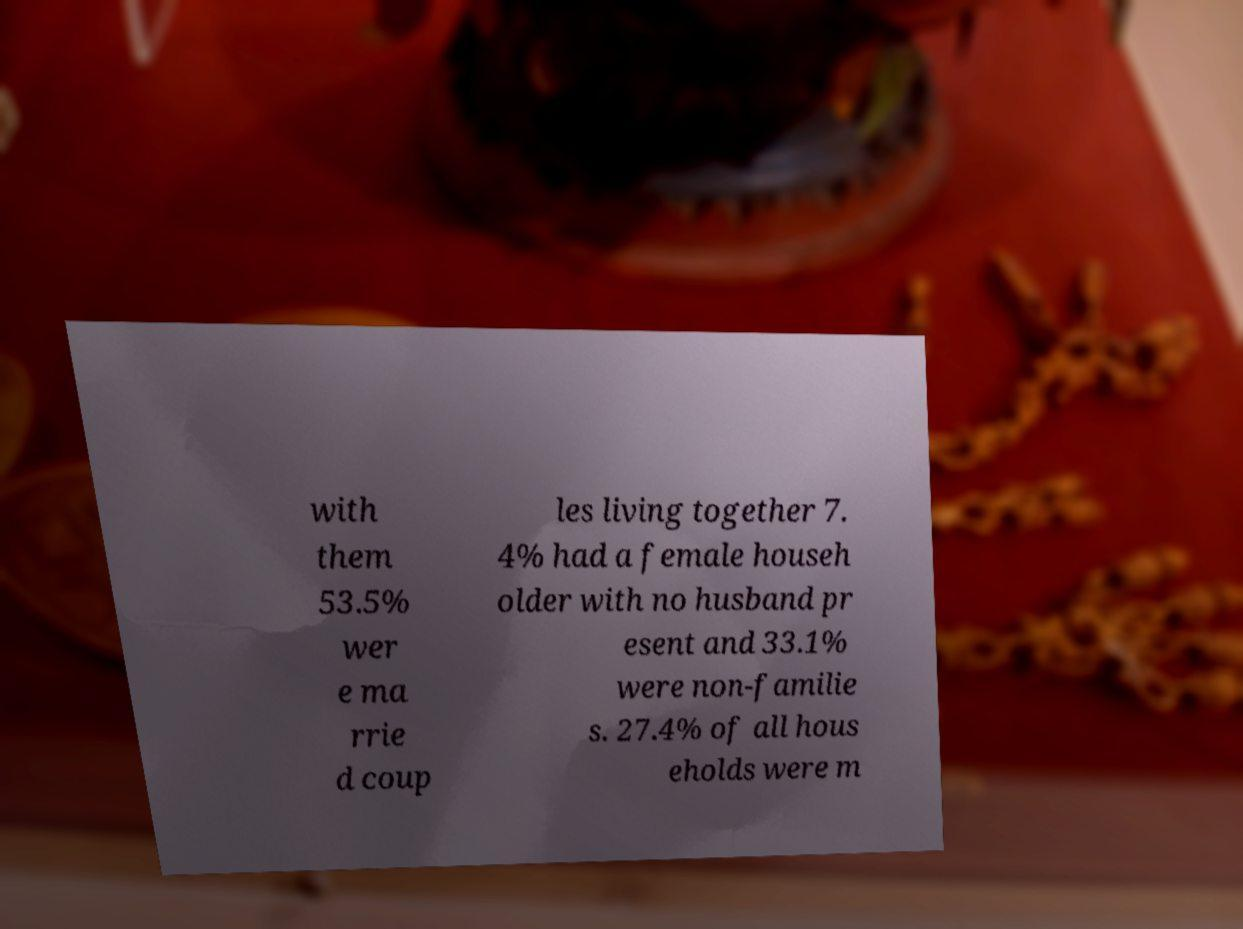Could you extract and type out the text from this image? with them 53.5% wer e ma rrie d coup les living together 7. 4% had a female househ older with no husband pr esent and 33.1% were non-familie s. 27.4% of all hous eholds were m 